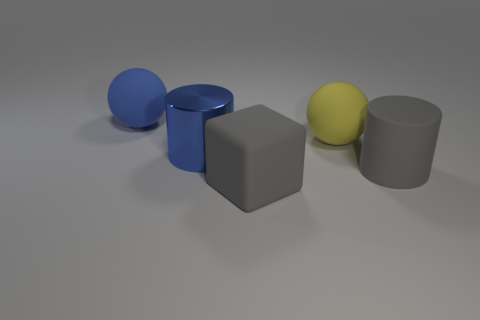There is a thing that is the same color as the large rubber cylinder; what is it made of?
Keep it short and to the point. Rubber. There is another large matte thing that is the same shape as the yellow rubber thing; what is its color?
Your answer should be very brief. Blue. How many objects are big blue things or objects that are in front of the large gray cylinder?
Ensure brevity in your answer.  3. Are there fewer large yellow things in front of the gray rubber cylinder than cylinders?
Your response must be concise. Yes. How big is the ball that is behind the matte sphere that is right of the big gray object on the left side of the big gray cylinder?
Ensure brevity in your answer.  Large. There is a large matte thing that is in front of the large yellow object and to the right of the big matte cube; what color is it?
Your response must be concise. Gray. What number of large yellow matte balls are there?
Your answer should be very brief. 1. Is there anything else that has the same size as the gray cylinder?
Your answer should be compact. Yes. Is the material of the large cube the same as the gray cylinder?
Give a very brief answer. Yes. Do the thing that is right of the big yellow rubber object and the rubber sphere that is to the left of the blue metallic cylinder have the same size?
Your answer should be compact. Yes. 